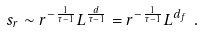<formula> <loc_0><loc_0><loc_500><loc_500>s _ { r } \sim r ^ { - \frac { 1 } { \tau - 1 } } L ^ { \frac { d } { \tau - 1 } } = r ^ { - \frac { 1 } { \tau - 1 } } L ^ { d _ { f } } \ .</formula> 